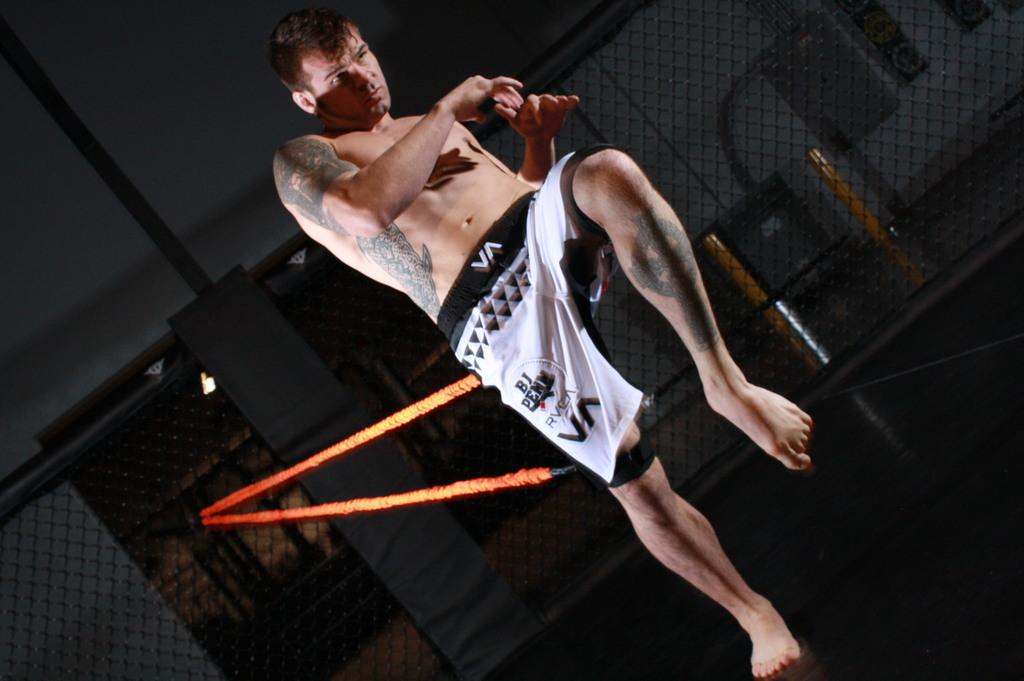<image>
Provide a brief description of the given image. A man wears boxing trunks, on the waste band are the letters VA. 